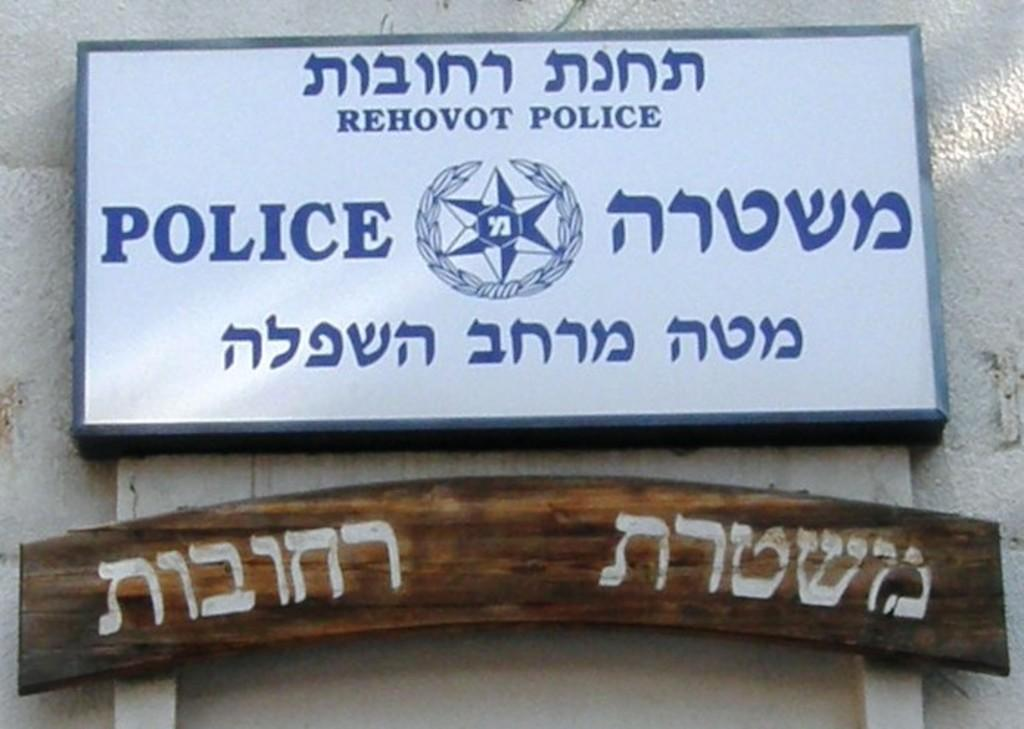<image>
Offer a succinct explanation of the picture presented. A sign in Hebrew for the Rehovot Police 